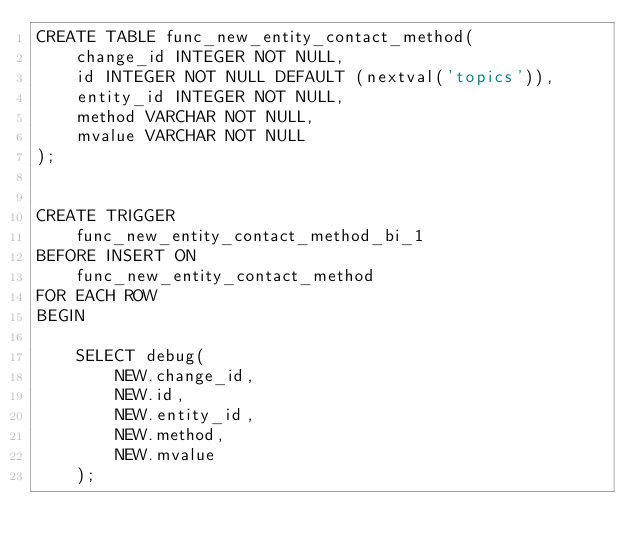Convert code to text. <code><loc_0><loc_0><loc_500><loc_500><_SQL_>CREATE TABLE func_new_entity_contact_method(
    change_id INTEGER NOT NULL,
    id INTEGER NOT NULL DEFAULT (nextval('topics')),
    entity_id INTEGER NOT NULL,
    method VARCHAR NOT NULL,
    mvalue VARCHAR NOT NULL
);


CREATE TRIGGER
    func_new_entity_contact_method_bi_1
BEFORE INSERT ON
    func_new_entity_contact_method
FOR EACH ROW
BEGIN

    SELECT debug(
        NEW.change_id,
        NEW.id,
        NEW.entity_id,
        NEW.method,
        NEW.mvalue
    );

</code> 